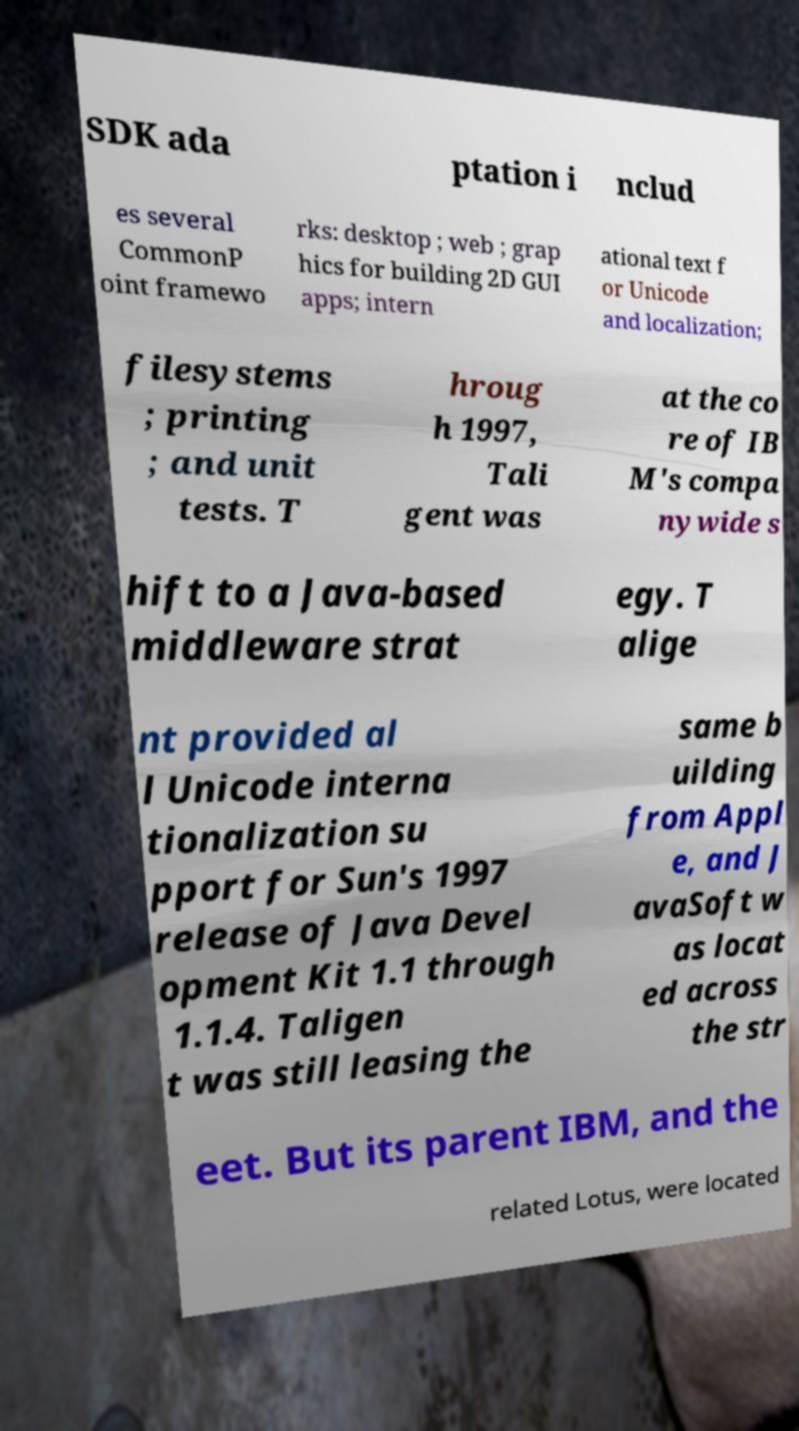For documentation purposes, I need the text within this image transcribed. Could you provide that? SDK ada ptation i nclud es several CommonP oint framewo rks: desktop ; web ; grap hics for building 2D GUI apps; intern ational text f or Unicode and localization; filesystems ; printing ; and unit tests. T hroug h 1997, Tali gent was at the co re of IB M's compa nywide s hift to a Java-based middleware strat egy. T alige nt provided al l Unicode interna tionalization su pport for Sun's 1997 release of Java Devel opment Kit 1.1 through 1.1.4. Taligen t was still leasing the same b uilding from Appl e, and J avaSoft w as locat ed across the str eet. But its parent IBM, and the related Lotus, were located 